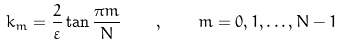Convert formula to latex. <formula><loc_0><loc_0><loc_500><loc_500>k _ { m } = \frac { 2 } { \varepsilon } \tan \frac { \pi m } { N } \quad , \quad m = 0 , 1 , \dots , N - 1</formula> 